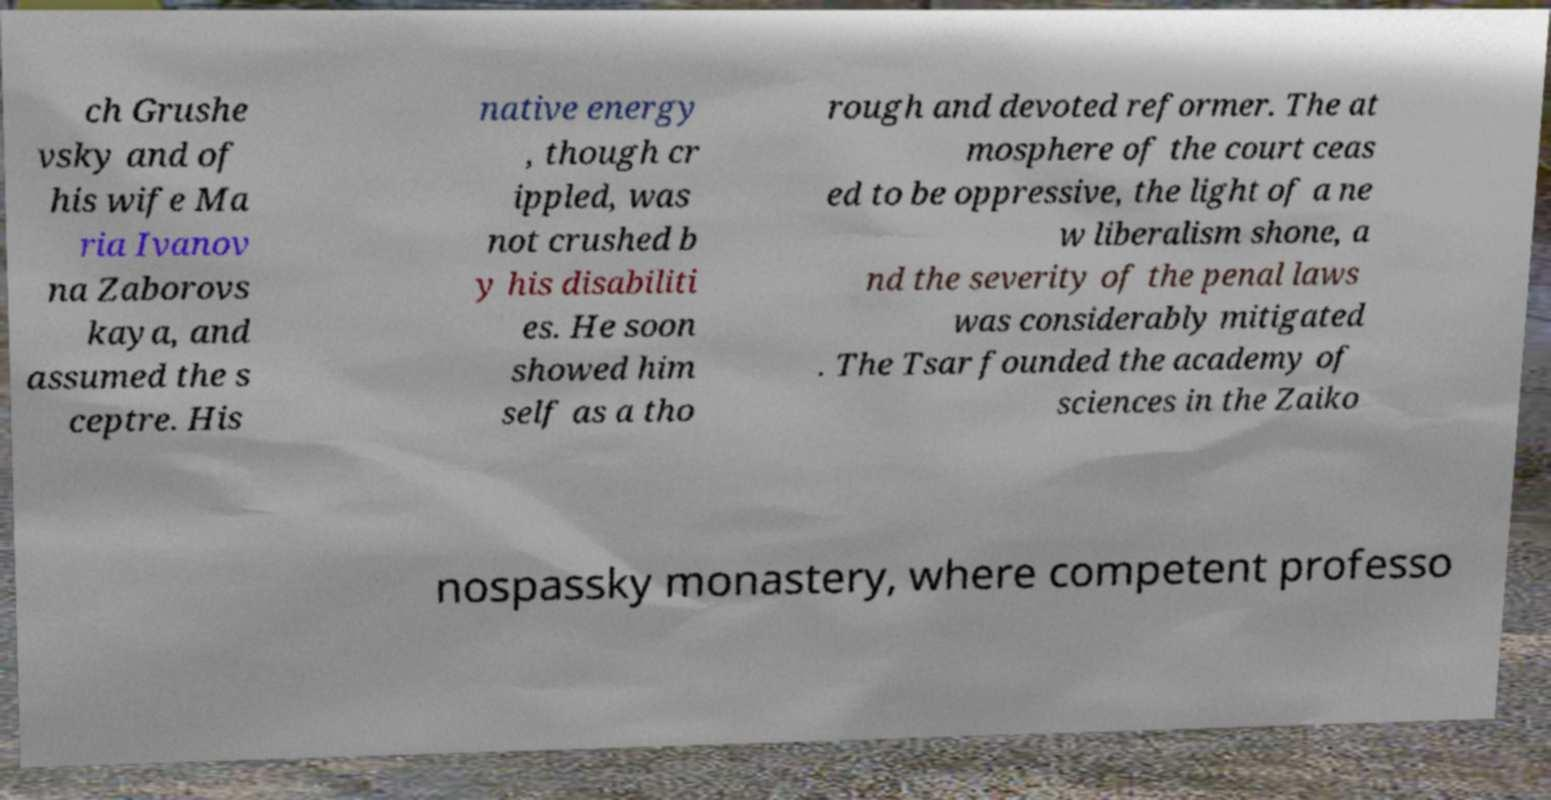Could you extract and type out the text from this image? ch Grushe vsky and of his wife Ma ria Ivanov na Zaborovs kaya, and assumed the s ceptre. His native energy , though cr ippled, was not crushed b y his disabiliti es. He soon showed him self as a tho rough and devoted reformer. The at mosphere of the court ceas ed to be oppressive, the light of a ne w liberalism shone, a nd the severity of the penal laws was considerably mitigated . The Tsar founded the academy of sciences in the Zaiko nospassky monastery, where competent professo 